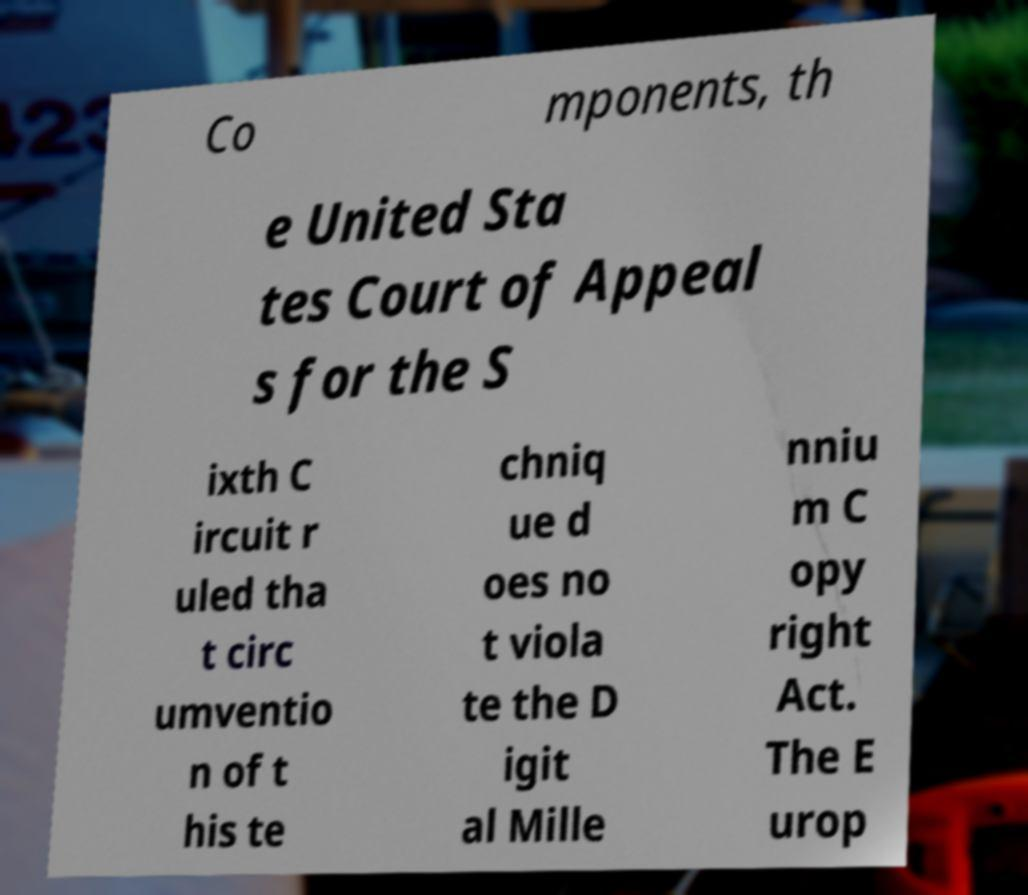There's text embedded in this image that I need extracted. Can you transcribe it verbatim? Co mponents, th e United Sta tes Court of Appeal s for the S ixth C ircuit r uled tha t circ umventio n of t his te chniq ue d oes no t viola te the D igit al Mille nniu m C opy right Act. The E urop 